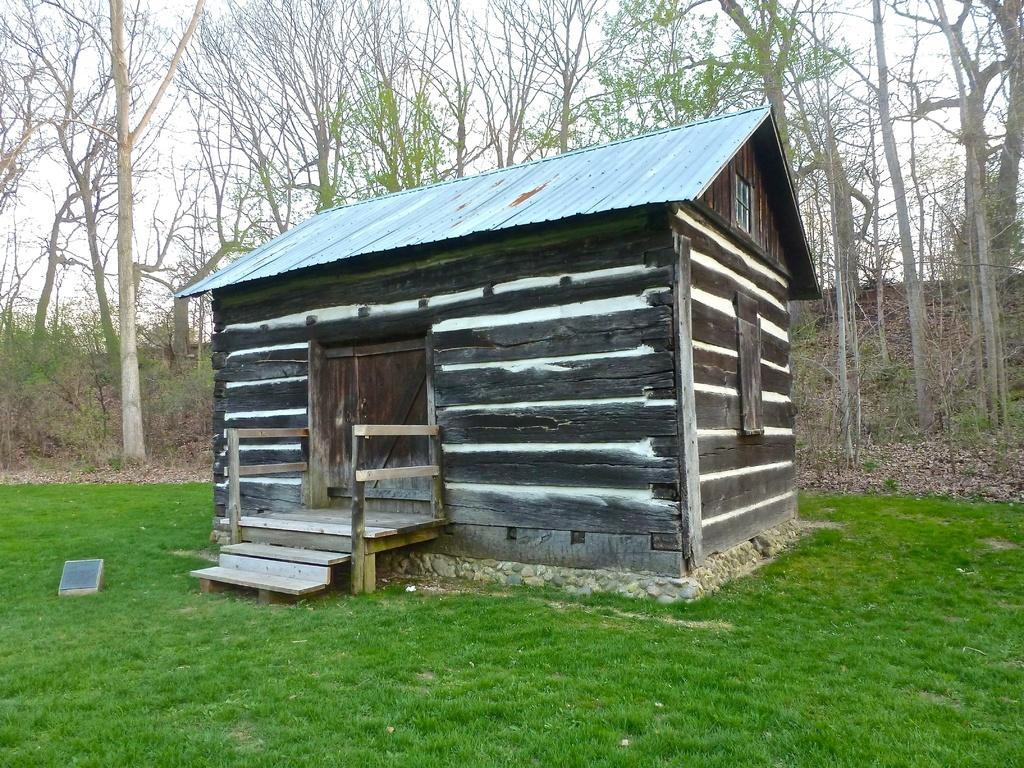What type of ground covering is visible in the image? The ground in the image is covered with grass. What kind of house is present in the image? There is a wooden house in the image. What material is used for the roof of the house? The house has an iron sheet roof. What can be seen behind the house in the image? There are trees visible behind the house. How much milk is being poured into the plate in the image? There is no milk or plate present in the image. What is the level of wealth depicted in the image? The image does not provide any information about the level of wealth; it only shows a wooden house with an iron sheet roof and trees in the background. 